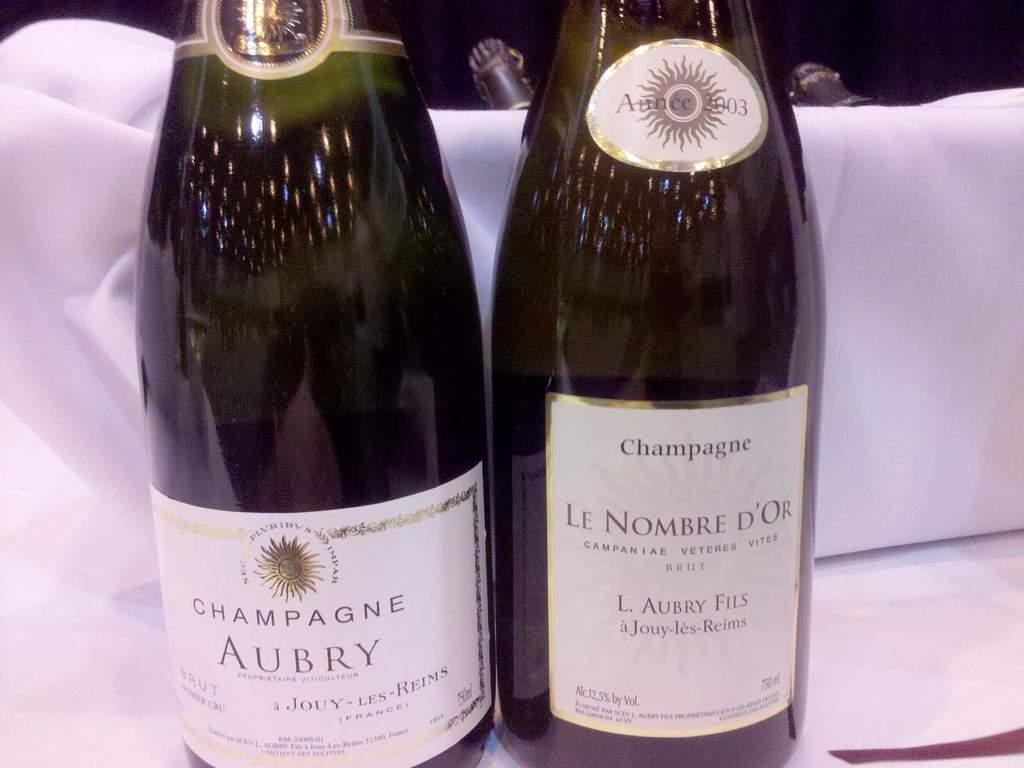Provide a one-sentence caption for the provided image. A bottle of Aubry and Le Nombre Champagne sit on the table. 